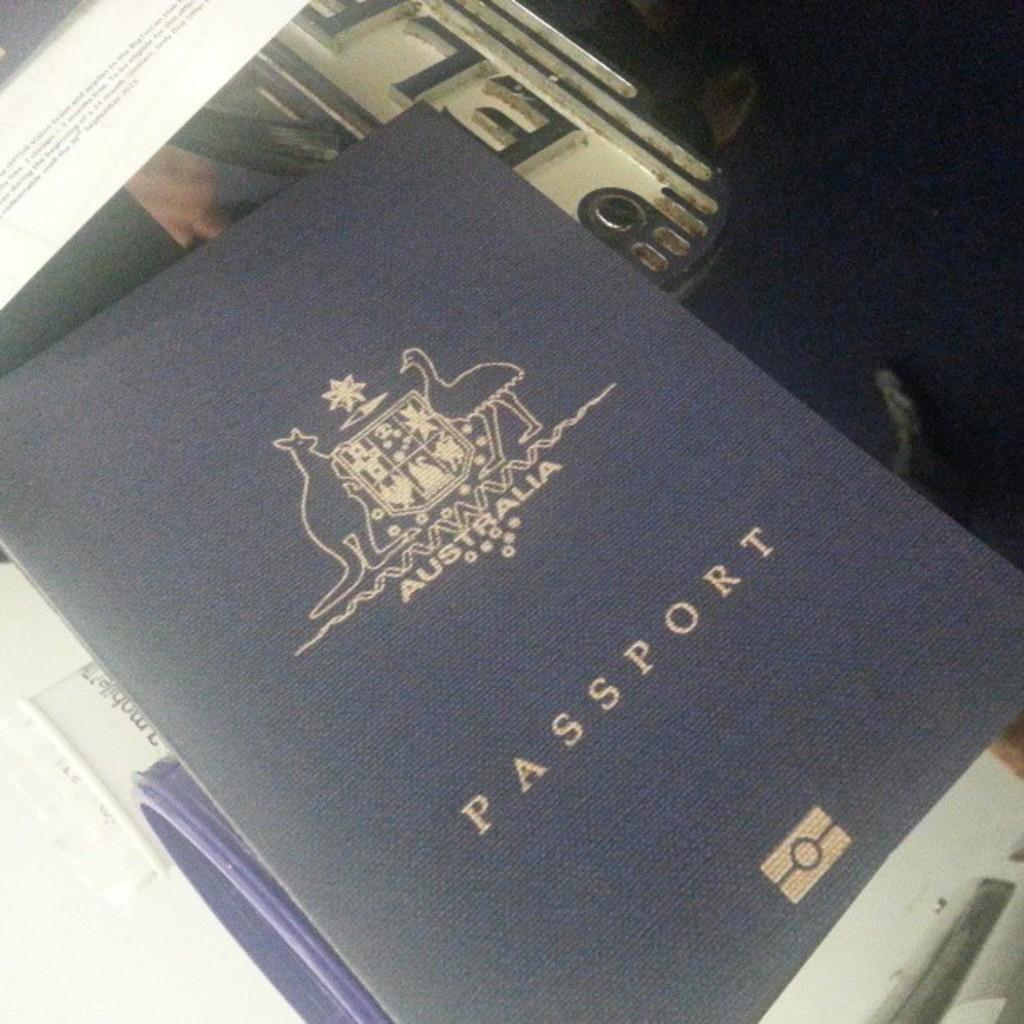<image>
Render a clear and concise summary of the photo. Blue passport that says Austalia on it and shows a kangaroo. 